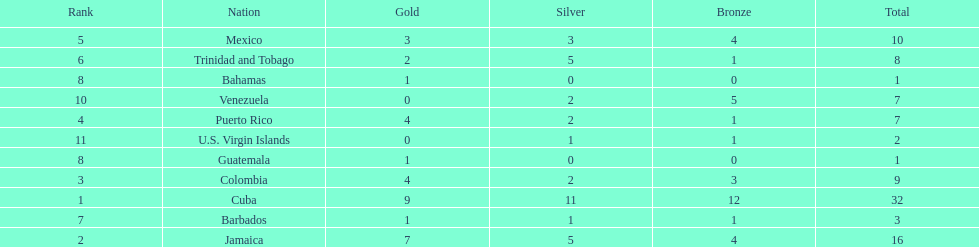Which nations played in the games? Cuba, Jamaica, Colombia, Puerto Rico, Mexico, Trinidad and Tobago, Barbados, Guatemala, Bahamas, Venezuela, U.S. Virgin Islands. How many silver medals did they win? 11, 5, 2, 2, 3, 5, 1, 0, 0, 2, 1. Which team won the most silver? Cuba. 